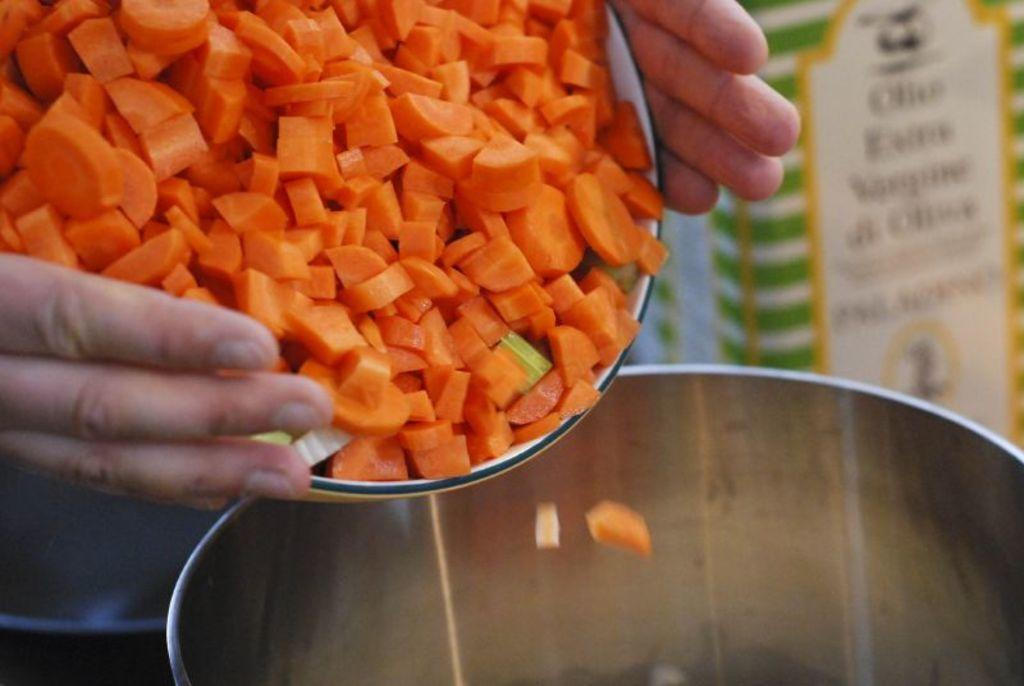What is being held by the human hands in the image? The human hands are holding a bowl in the image. What is inside the bowl? The bowl contains chopped carrots. What action are the hands performing with the bowl? The hands are attempting to pour the carrots into another container. Can you describe the background of the image? The background of the image is blurred. What other objects can be seen in the image besides the bowl and hands? There is at least one box visible in the image. How does the person in the image express impulse while holding the bowl? There is no indication of impulse or any emotional expression in the image; it only shows human hands holding a bowl with chopped carrots. 